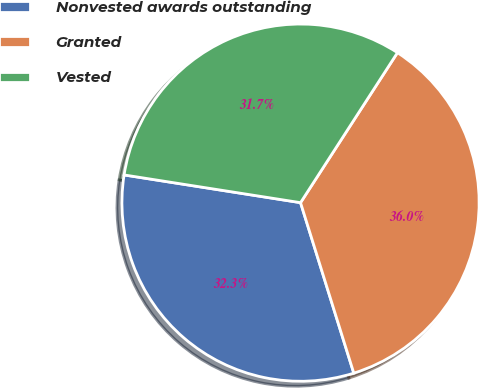<chart> <loc_0><loc_0><loc_500><loc_500><pie_chart><fcel>Nonvested awards outstanding<fcel>Granted<fcel>Vested<nl><fcel>32.3%<fcel>36.05%<fcel>31.65%<nl></chart> 